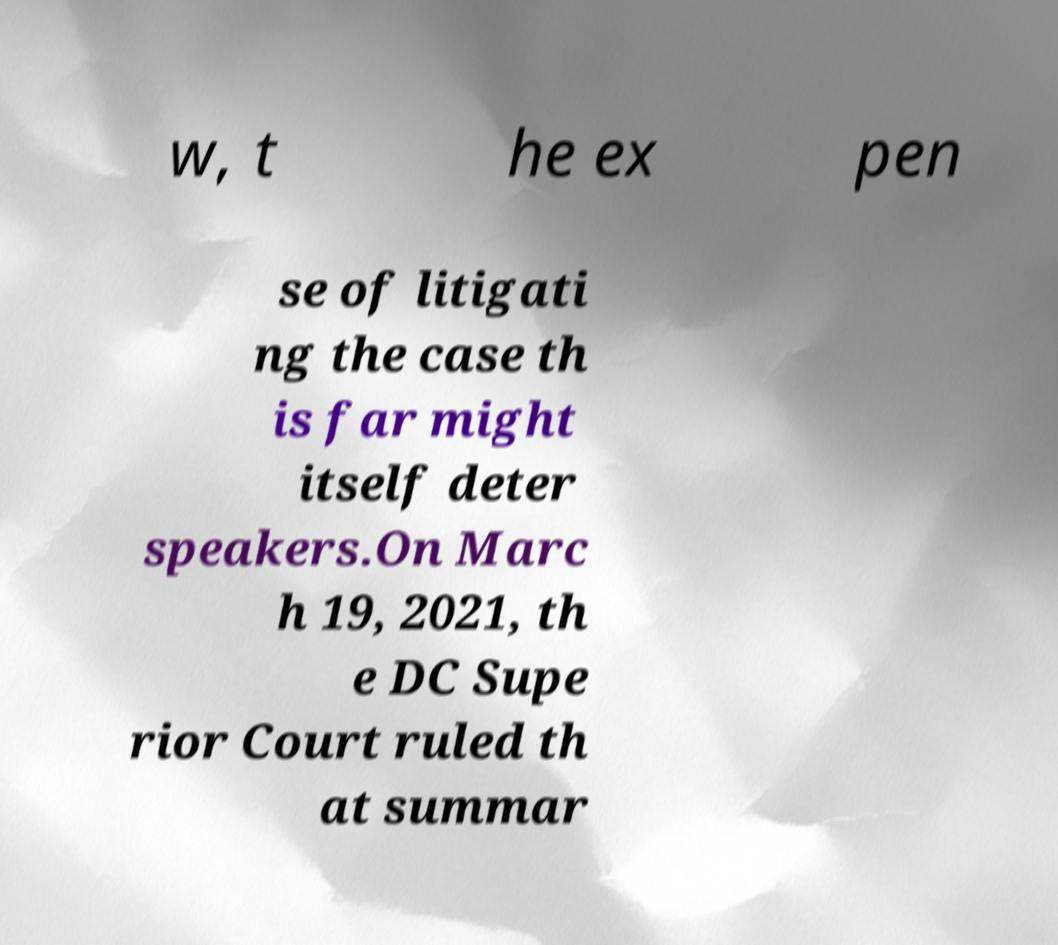Please read and relay the text visible in this image. What does it say? w, t he ex pen se of litigati ng the case th is far might itself deter speakers.On Marc h 19, 2021, th e DC Supe rior Court ruled th at summar 